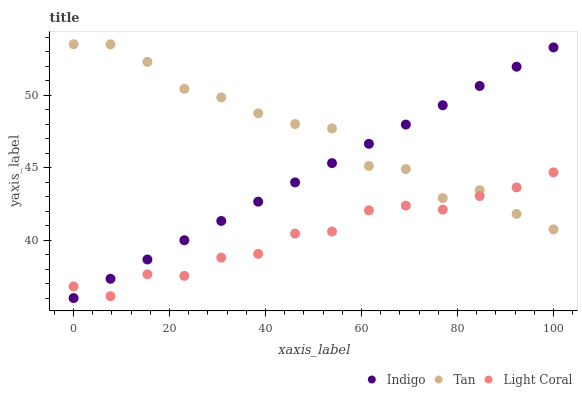Does Light Coral have the minimum area under the curve?
Answer yes or no. Yes. Does Tan have the maximum area under the curve?
Answer yes or no. Yes. Does Indigo have the minimum area under the curve?
Answer yes or no. No. Does Indigo have the maximum area under the curve?
Answer yes or no. No. Is Indigo the smoothest?
Answer yes or no. Yes. Is Tan the roughest?
Answer yes or no. Yes. Is Tan the smoothest?
Answer yes or no. No. Is Indigo the roughest?
Answer yes or no. No. Does Indigo have the lowest value?
Answer yes or no. Yes. Does Tan have the lowest value?
Answer yes or no. No. Does Tan have the highest value?
Answer yes or no. Yes. Does Indigo have the highest value?
Answer yes or no. No. Does Indigo intersect Light Coral?
Answer yes or no. Yes. Is Indigo less than Light Coral?
Answer yes or no. No. Is Indigo greater than Light Coral?
Answer yes or no. No. 